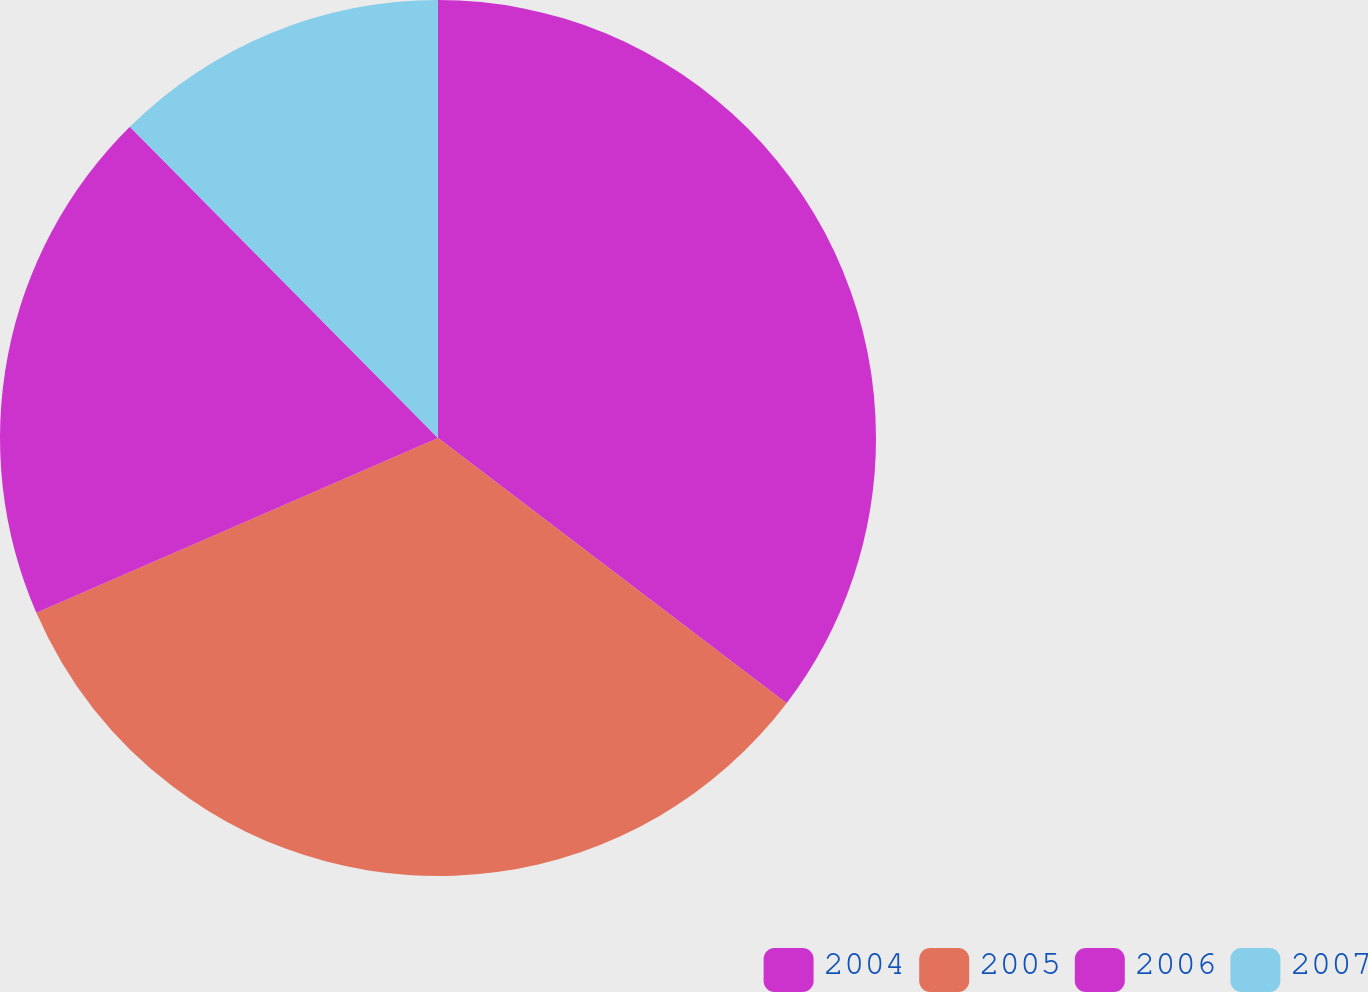<chart> <loc_0><loc_0><loc_500><loc_500><pie_chart><fcel>2004<fcel>2005<fcel>2006<fcel>2007<nl><fcel>35.35%<fcel>33.12%<fcel>19.11%<fcel>12.42%<nl></chart> 